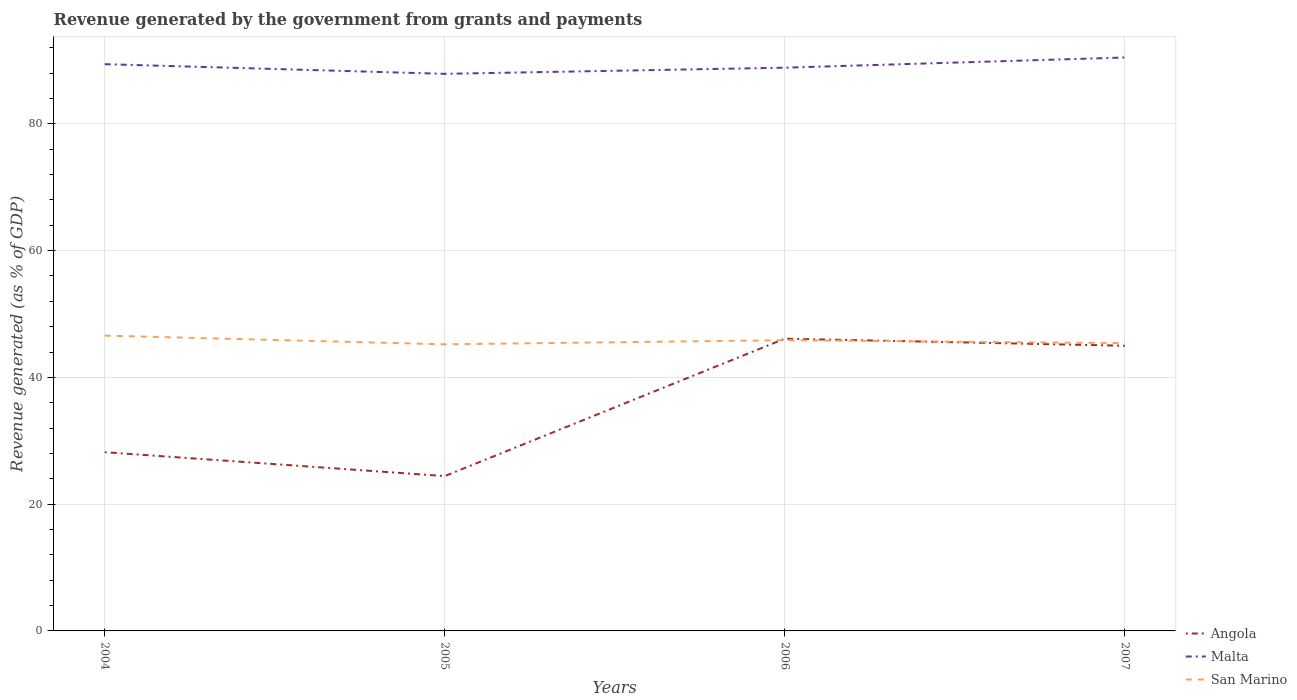How many different coloured lines are there?
Your response must be concise. 3. Across all years, what is the maximum revenue generated by the government in San Marino?
Ensure brevity in your answer.  45.22. What is the total revenue generated by the government in Angola in the graph?
Provide a succinct answer. -21.68. What is the difference between the highest and the second highest revenue generated by the government in Angola?
Provide a short and direct response. 21.68. What is the difference between the highest and the lowest revenue generated by the government in Malta?
Provide a short and direct response. 2. Is the revenue generated by the government in Angola strictly greater than the revenue generated by the government in Malta over the years?
Provide a short and direct response. Yes. How many years are there in the graph?
Your response must be concise. 4. How are the legend labels stacked?
Keep it short and to the point. Vertical. What is the title of the graph?
Provide a succinct answer. Revenue generated by the government from grants and payments. Does "Brazil" appear as one of the legend labels in the graph?
Give a very brief answer. No. What is the label or title of the Y-axis?
Provide a succinct answer. Revenue generated (as % of GDP). What is the Revenue generated (as % of GDP) in Angola in 2004?
Make the answer very short. 28.2. What is the Revenue generated (as % of GDP) of Malta in 2004?
Make the answer very short. 89.41. What is the Revenue generated (as % of GDP) in San Marino in 2004?
Offer a terse response. 46.59. What is the Revenue generated (as % of GDP) of Angola in 2005?
Provide a succinct answer. 24.43. What is the Revenue generated (as % of GDP) of Malta in 2005?
Keep it short and to the point. 87.89. What is the Revenue generated (as % of GDP) in San Marino in 2005?
Provide a short and direct response. 45.22. What is the Revenue generated (as % of GDP) in Angola in 2006?
Your response must be concise. 46.1. What is the Revenue generated (as % of GDP) in Malta in 2006?
Offer a very short reply. 88.85. What is the Revenue generated (as % of GDP) of San Marino in 2006?
Ensure brevity in your answer.  45.86. What is the Revenue generated (as % of GDP) in Angola in 2007?
Give a very brief answer. 44.99. What is the Revenue generated (as % of GDP) in Malta in 2007?
Offer a terse response. 90.46. What is the Revenue generated (as % of GDP) in San Marino in 2007?
Offer a very short reply. 45.4. Across all years, what is the maximum Revenue generated (as % of GDP) of Angola?
Offer a terse response. 46.1. Across all years, what is the maximum Revenue generated (as % of GDP) of Malta?
Your answer should be very brief. 90.46. Across all years, what is the maximum Revenue generated (as % of GDP) of San Marino?
Offer a very short reply. 46.59. Across all years, what is the minimum Revenue generated (as % of GDP) in Angola?
Provide a short and direct response. 24.43. Across all years, what is the minimum Revenue generated (as % of GDP) in Malta?
Your answer should be very brief. 87.89. Across all years, what is the minimum Revenue generated (as % of GDP) in San Marino?
Your answer should be compact. 45.22. What is the total Revenue generated (as % of GDP) of Angola in the graph?
Provide a short and direct response. 143.71. What is the total Revenue generated (as % of GDP) in Malta in the graph?
Give a very brief answer. 356.6. What is the total Revenue generated (as % of GDP) in San Marino in the graph?
Make the answer very short. 183.07. What is the difference between the Revenue generated (as % of GDP) in Angola in 2004 and that in 2005?
Keep it short and to the point. 3.77. What is the difference between the Revenue generated (as % of GDP) of Malta in 2004 and that in 2005?
Keep it short and to the point. 1.52. What is the difference between the Revenue generated (as % of GDP) in San Marino in 2004 and that in 2005?
Give a very brief answer. 1.37. What is the difference between the Revenue generated (as % of GDP) in Angola in 2004 and that in 2006?
Offer a terse response. -17.91. What is the difference between the Revenue generated (as % of GDP) of Malta in 2004 and that in 2006?
Keep it short and to the point. 0.56. What is the difference between the Revenue generated (as % of GDP) of San Marino in 2004 and that in 2006?
Keep it short and to the point. 0.72. What is the difference between the Revenue generated (as % of GDP) in Angola in 2004 and that in 2007?
Your answer should be very brief. -16.79. What is the difference between the Revenue generated (as % of GDP) in Malta in 2004 and that in 2007?
Your response must be concise. -1.05. What is the difference between the Revenue generated (as % of GDP) in San Marino in 2004 and that in 2007?
Provide a succinct answer. 1.18. What is the difference between the Revenue generated (as % of GDP) in Angola in 2005 and that in 2006?
Your answer should be very brief. -21.68. What is the difference between the Revenue generated (as % of GDP) of Malta in 2005 and that in 2006?
Your response must be concise. -0.97. What is the difference between the Revenue generated (as % of GDP) in San Marino in 2005 and that in 2006?
Offer a terse response. -0.64. What is the difference between the Revenue generated (as % of GDP) in Angola in 2005 and that in 2007?
Provide a succinct answer. -20.56. What is the difference between the Revenue generated (as % of GDP) of Malta in 2005 and that in 2007?
Give a very brief answer. -2.57. What is the difference between the Revenue generated (as % of GDP) of San Marino in 2005 and that in 2007?
Offer a very short reply. -0.19. What is the difference between the Revenue generated (as % of GDP) in Angola in 2006 and that in 2007?
Your answer should be compact. 1.12. What is the difference between the Revenue generated (as % of GDP) of Malta in 2006 and that in 2007?
Give a very brief answer. -1.61. What is the difference between the Revenue generated (as % of GDP) in San Marino in 2006 and that in 2007?
Offer a very short reply. 0.46. What is the difference between the Revenue generated (as % of GDP) in Angola in 2004 and the Revenue generated (as % of GDP) in Malta in 2005?
Your answer should be compact. -59.69. What is the difference between the Revenue generated (as % of GDP) in Angola in 2004 and the Revenue generated (as % of GDP) in San Marino in 2005?
Give a very brief answer. -17.02. What is the difference between the Revenue generated (as % of GDP) in Malta in 2004 and the Revenue generated (as % of GDP) in San Marino in 2005?
Keep it short and to the point. 44.19. What is the difference between the Revenue generated (as % of GDP) in Angola in 2004 and the Revenue generated (as % of GDP) in Malta in 2006?
Ensure brevity in your answer.  -60.65. What is the difference between the Revenue generated (as % of GDP) in Angola in 2004 and the Revenue generated (as % of GDP) in San Marino in 2006?
Ensure brevity in your answer.  -17.67. What is the difference between the Revenue generated (as % of GDP) of Malta in 2004 and the Revenue generated (as % of GDP) of San Marino in 2006?
Give a very brief answer. 43.55. What is the difference between the Revenue generated (as % of GDP) of Angola in 2004 and the Revenue generated (as % of GDP) of Malta in 2007?
Provide a succinct answer. -62.26. What is the difference between the Revenue generated (as % of GDP) of Angola in 2004 and the Revenue generated (as % of GDP) of San Marino in 2007?
Keep it short and to the point. -17.21. What is the difference between the Revenue generated (as % of GDP) in Malta in 2004 and the Revenue generated (as % of GDP) in San Marino in 2007?
Offer a terse response. 44. What is the difference between the Revenue generated (as % of GDP) in Angola in 2005 and the Revenue generated (as % of GDP) in Malta in 2006?
Give a very brief answer. -64.43. What is the difference between the Revenue generated (as % of GDP) of Angola in 2005 and the Revenue generated (as % of GDP) of San Marino in 2006?
Keep it short and to the point. -21.44. What is the difference between the Revenue generated (as % of GDP) in Malta in 2005 and the Revenue generated (as % of GDP) in San Marino in 2006?
Ensure brevity in your answer.  42.02. What is the difference between the Revenue generated (as % of GDP) of Angola in 2005 and the Revenue generated (as % of GDP) of Malta in 2007?
Keep it short and to the point. -66.03. What is the difference between the Revenue generated (as % of GDP) in Angola in 2005 and the Revenue generated (as % of GDP) in San Marino in 2007?
Your answer should be very brief. -20.98. What is the difference between the Revenue generated (as % of GDP) in Malta in 2005 and the Revenue generated (as % of GDP) in San Marino in 2007?
Make the answer very short. 42.48. What is the difference between the Revenue generated (as % of GDP) of Angola in 2006 and the Revenue generated (as % of GDP) of Malta in 2007?
Your answer should be compact. -44.36. What is the difference between the Revenue generated (as % of GDP) in Angola in 2006 and the Revenue generated (as % of GDP) in San Marino in 2007?
Provide a short and direct response. 0.7. What is the difference between the Revenue generated (as % of GDP) in Malta in 2006 and the Revenue generated (as % of GDP) in San Marino in 2007?
Offer a terse response. 43.45. What is the average Revenue generated (as % of GDP) of Angola per year?
Your response must be concise. 35.93. What is the average Revenue generated (as % of GDP) of Malta per year?
Ensure brevity in your answer.  89.15. What is the average Revenue generated (as % of GDP) of San Marino per year?
Provide a short and direct response. 45.77. In the year 2004, what is the difference between the Revenue generated (as % of GDP) of Angola and Revenue generated (as % of GDP) of Malta?
Your response must be concise. -61.21. In the year 2004, what is the difference between the Revenue generated (as % of GDP) of Angola and Revenue generated (as % of GDP) of San Marino?
Your answer should be very brief. -18.39. In the year 2004, what is the difference between the Revenue generated (as % of GDP) in Malta and Revenue generated (as % of GDP) in San Marino?
Ensure brevity in your answer.  42.82. In the year 2005, what is the difference between the Revenue generated (as % of GDP) in Angola and Revenue generated (as % of GDP) in Malta?
Your answer should be very brief. -63.46. In the year 2005, what is the difference between the Revenue generated (as % of GDP) in Angola and Revenue generated (as % of GDP) in San Marino?
Keep it short and to the point. -20.79. In the year 2005, what is the difference between the Revenue generated (as % of GDP) of Malta and Revenue generated (as % of GDP) of San Marino?
Ensure brevity in your answer.  42.67. In the year 2006, what is the difference between the Revenue generated (as % of GDP) in Angola and Revenue generated (as % of GDP) in Malta?
Your response must be concise. -42.75. In the year 2006, what is the difference between the Revenue generated (as % of GDP) in Angola and Revenue generated (as % of GDP) in San Marino?
Offer a terse response. 0.24. In the year 2006, what is the difference between the Revenue generated (as % of GDP) in Malta and Revenue generated (as % of GDP) in San Marino?
Give a very brief answer. 42.99. In the year 2007, what is the difference between the Revenue generated (as % of GDP) in Angola and Revenue generated (as % of GDP) in Malta?
Offer a terse response. -45.47. In the year 2007, what is the difference between the Revenue generated (as % of GDP) of Angola and Revenue generated (as % of GDP) of San Marino?
Provide a short and direct response. -0.42. In the year 2007, what is the difference between the Revenue generated (as % of GDP) of Malta and Revenue generated (as % of GDP) of San Marino?
Offer a terse response. 45.06. What is the ratio of the Revenue generated (as % of GDP) of Angola in 2004 to that in 2005?
Provide a short and direct response. 1.15. What is the ratio of the Revenue generated (as % of GDP) in Malta in 2004 to that in 2005?
Provide a succinct answer. 1.02. What is the ratio of the Revenue generated (as % of GDP) of San Marino in 2004 to that in 2005?
Give a very brief answer. 1.03. What is the ratio of the Revenue generated (as % of GDP) of Angola in 2004 to that in 2006?
Provide a short and direct response. 0.61. What is the ratio of the Revenue generated (as % of GDP) of Malta in 2004 to that in 2006?
Your response must be concise. 1.01. What is the ratio of the Revenue generated (as % of GDP) of San Marino in 2004 to that in 2006?
Keep it short and to the point. 1.02. What is the ratio of the Revenue generated (as % of GDP) in Angola in 2004 to that in 2007?
Your response must be concise. 0.63. What is the ratio of the Revenue generated (as % of GDP) in Malta in 2004 to that in 2007?
Your answer should be very brief. 0.99. What is the ratio of the Revenue generated (as % of GDP) of San Marino in 2004 to that in 2007?
Your answer should be compact. 1.03. What is the ratio of the Revenue generated (as % of GDP) of Angola in 2005 to that in 2006?
Offer a terse response. 0.53. What is the ratio of the Revenue generated (as % of GDP) of Malta in 2005 to that in 2006?
Your answer should be compact. 0.99. What is the ratio of the Revenue generated (as % of GDP) of Angola in 2005 to that in 2007?
Make the answer very short. 0.54. What is the ratio of the Revenue generated (as % of GDP) of Malta in 2005 to that in 2007?
Your response must be concise. 0.97. What is the ratio of the Revenue generated (as % of GDP) in San Marino in 2005 to that in 2007?
Your answer should be very brief. 1. What is the ratio of the Revenue generated (as % of GDP) of Angola in 2006 to that in 2007?
Give a very brief answer. 1.02. What is the ratio of the Revenue generated (as % of GDP) of Malta in 2006 to that in 2007?
Provide a succinct answer. 0.98. What is the difference between the highest and the second highest Revenue generated (as % of GDP) of Angola?
Keep it short and to the point. 1.12. What is the difference between the highest and the second highest Revenue generated (as % of GDP) of Malta?
Your answer should be compact. 1.05. What is the difference between the highest and the second highest Revenue generated (as % of GDP) in San Marino?
Your answer should be very brief. 0.72. What is the difference between the highest and the lowest Revenue generated (as % of GDP) in Angola?
Provide a succinct answer. 21.68. What is the difference between the highest and the lowest Revenue generated (as % of GDP) of Malta?
Keep it short and to the point. 2.57. What is the difference between the highest and the lowest Revenue generated (as % of GDP) in San Marino?
Your answer should be compact. 1.37. 